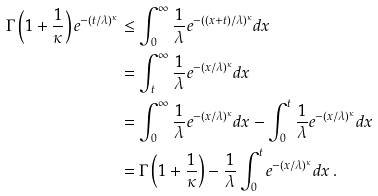Convert formula to latex. <formula><loc_0><loc_0><loc_500><loc_500>\Gamma \left ( 1 + \frac { 1 } { \kappa } \right ) e ^ { - ( t / \lambda ) ^ { \kappa } } & \leq \int _ { 0 } ^ { \infty } \frac { 1 } { \lambda } e ^ { - ( ( x + t ) / \lambda ) ^ { \kappa } } d x \\ & = \int _ { t } ^ { \infty } \frac { 1 } { \lambda } e ^ { - ( x / \lambda ) ^ { \kappa } } d x \\ & = \int _ { 0 } ^ { \infty } \frac { 1 } { \lambda } e ^ { - ( x / \lambda ) ^ { \kappa } } d x - \int _ { 0 } ^ { t } \frac { 1 } { \lambda } e ^ { - ( x / \lambda ) ^ { \kappa } } d x \\ & = \Gamma \left ( 1 + \frac { 1 } { \kappa } \right ) - \frac { 1 } { \lambda } \int _ { 0 } ^ { t } e ^ { - ( x / \lambda ) ^ { \kappa } } d x \, .</formula> 